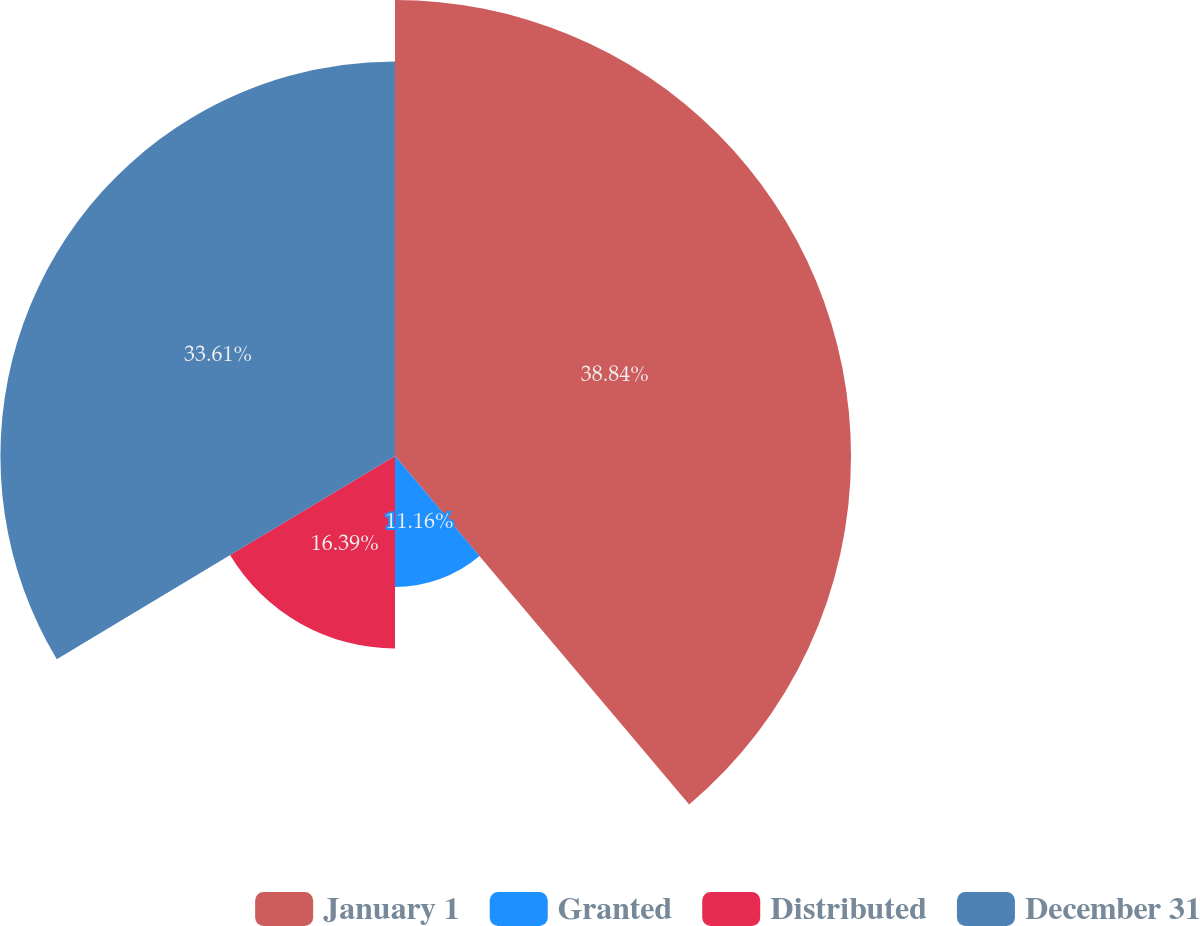<chart> <loc_0><loc_0><loc_500><loc_500><pie_chart><fcel>January 1<fcel>Granted<fcel>Distributed<fcel>December 31<nl><fcel>38.84%<fcel>11.16%<fcel>16.39%<fcel>33.61%<nl></chart> 